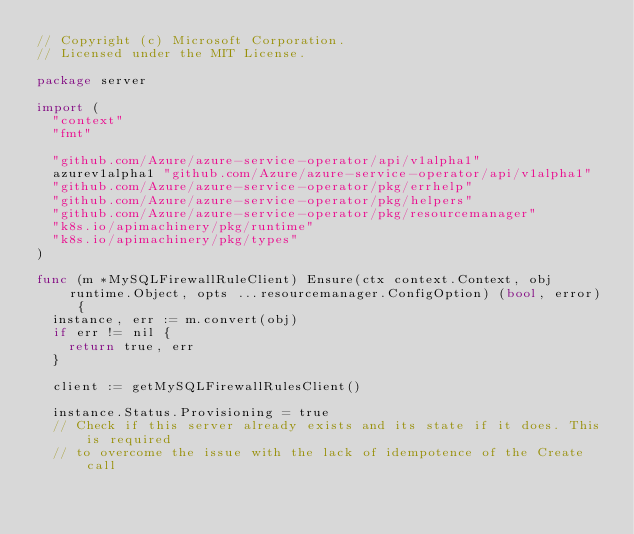Convert code to text. <code><loc_0><loc_0><loc_500><loc_500><_Go_>// Copyright (c) Microsoft Corporation.
// Licensed under the MIT License.

package server

import (
	"context"
	"fmt"

	"github.com/Azure/azure-service-operator/api/v1alpha1"
	azurev1alpha1 "github.com/Azure/azure-service-operator/api/v1alpha1"
	"github.com/Azure/azure-service-operator/pkg/errhelp"
	"github.com/Azure/azure-service-operator/pkg/helpers"
	"github.com/Azure/azure-service-operator/pkg/resourcemanager"
	"k8s.io/apimachinery/pkg/runtime"
	"k8s.io/apimachinery/pkg/types"
)

func (m *MySQLFirewallRuleClient) Ensure(ctx context.Context, obj runtime.Object, opts ...resourcemanager.ConfigOption) (bool, error) {
	instance, err := m.convert(obj)
	if err != nil {
		return true, err
	}

	client := getMySQLFirewallRulesClient()

	instance.Status.Provisioning = true
	// Check if this server already exists and its state if it does. This is required
	// to overcome the issue with the lack of idempotence of the Create call
</code> 